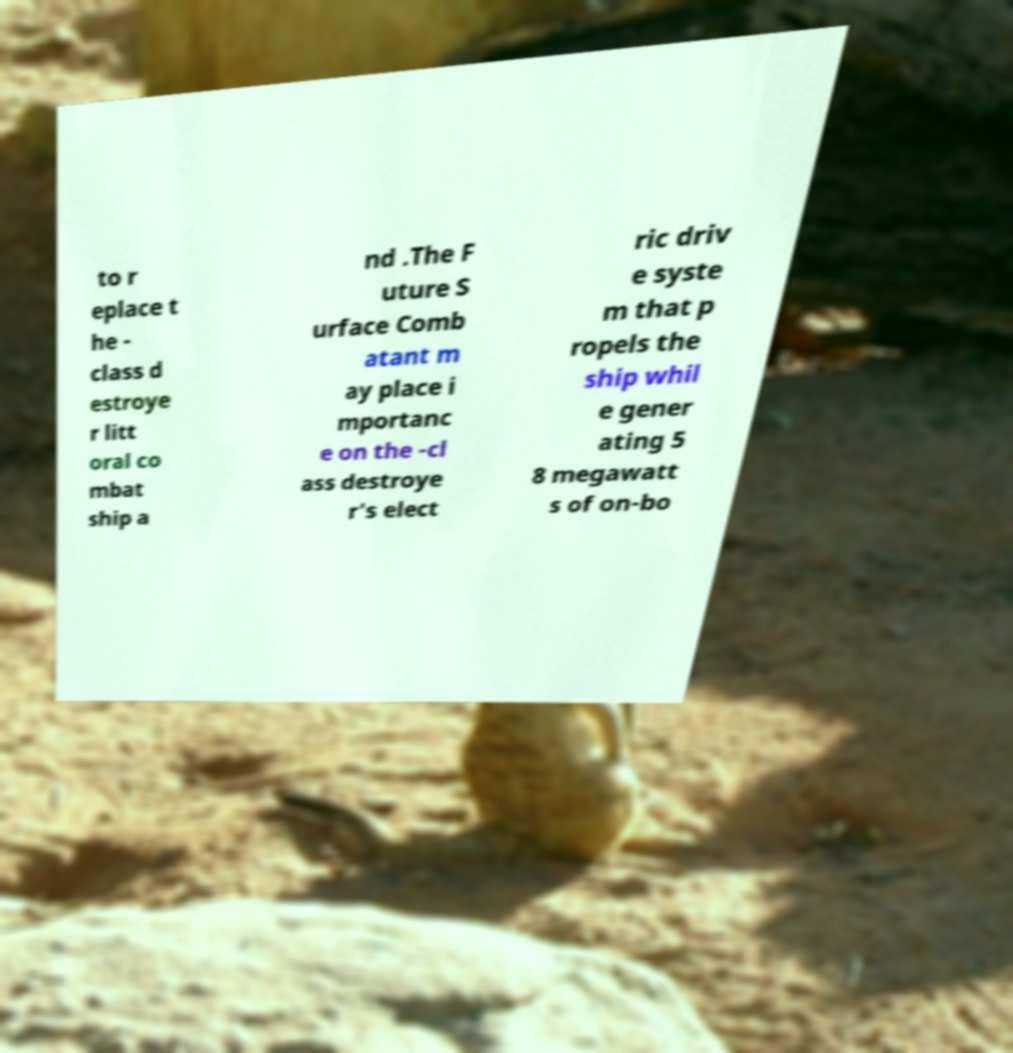I need the written content from this picture converted into text. Can you do that? to r eplace t he - class d estroye r litt oral co mbat ship a nd .The F uture S urface Comb atant m ay place i mportanc e on the -cl ass destroye r's elect ric driv e syste m that p ropels the ship whil e gener ating 5 8 megawatt s of on-bo 